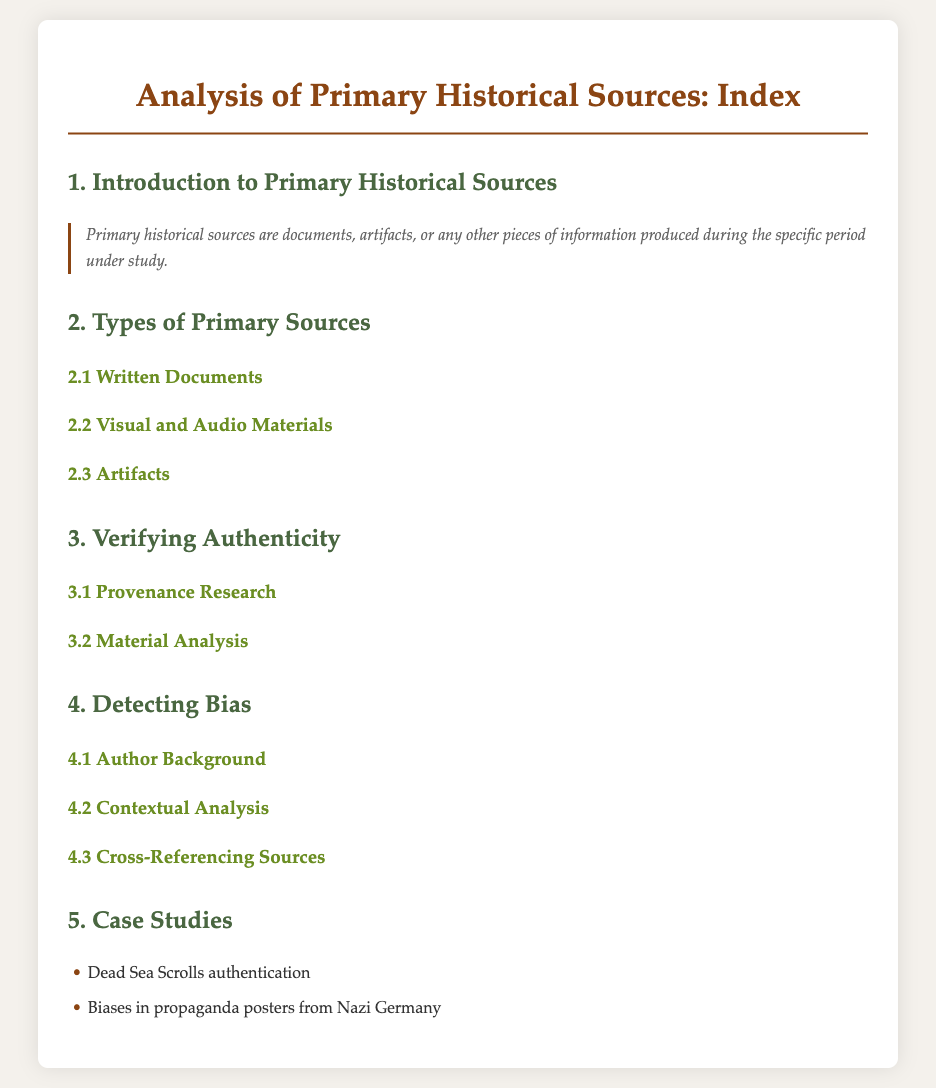What are primary historical sources? Primary historical sources are documents, artifacts, or any other pieces of information produced during the specific period under study.
Answer: Documents, artifacts, or any other pieces of information What are the types of primary sources mentioned? The types of primary sources listed include written documents, visual and audio materials, and artifacts.
Answer: Written documents, visual and audio materials, artifacts What is the first step in verifying authenticity? The first step in verifying authenticity is provenance research.
Answer: Provenance research What does detecting bias involve? Detecting bias involves analyzing the author's background, contextual analysis, and cross-referencing sources.
Answer: Author background, contextual analysis, cross-referencing sources What is one case study example provided? One case study example provided is the authentication of the Dead Sea Scrolls.
Answer: Dead Sea Scrolls authentication What color is used for the main title? The color used for the main title is #8B4513.
Answer: #8B4513 What is the main focus of section 4? The main focus of section 4 is detecting bias.
Answer: Detecting bias What is the quote regarding primary sources? The quote states that primary historical sources are documents, artifacts, or any pieces of information produced during the specific period under study.
Answer: Primary historical sources are documents, artifacts, or any pieces of information produced during the specific period under study 